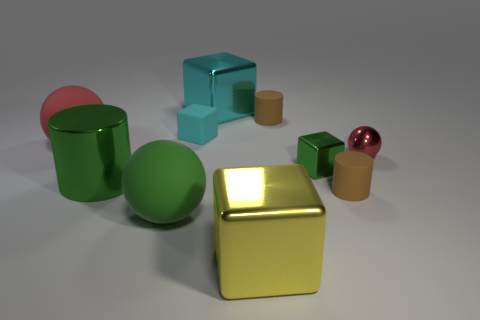Are there any shiny cubes that have the same color as the metal cylinder? Yes, there is one shiny cube that shares the same hue of green as the metal cylinder. 